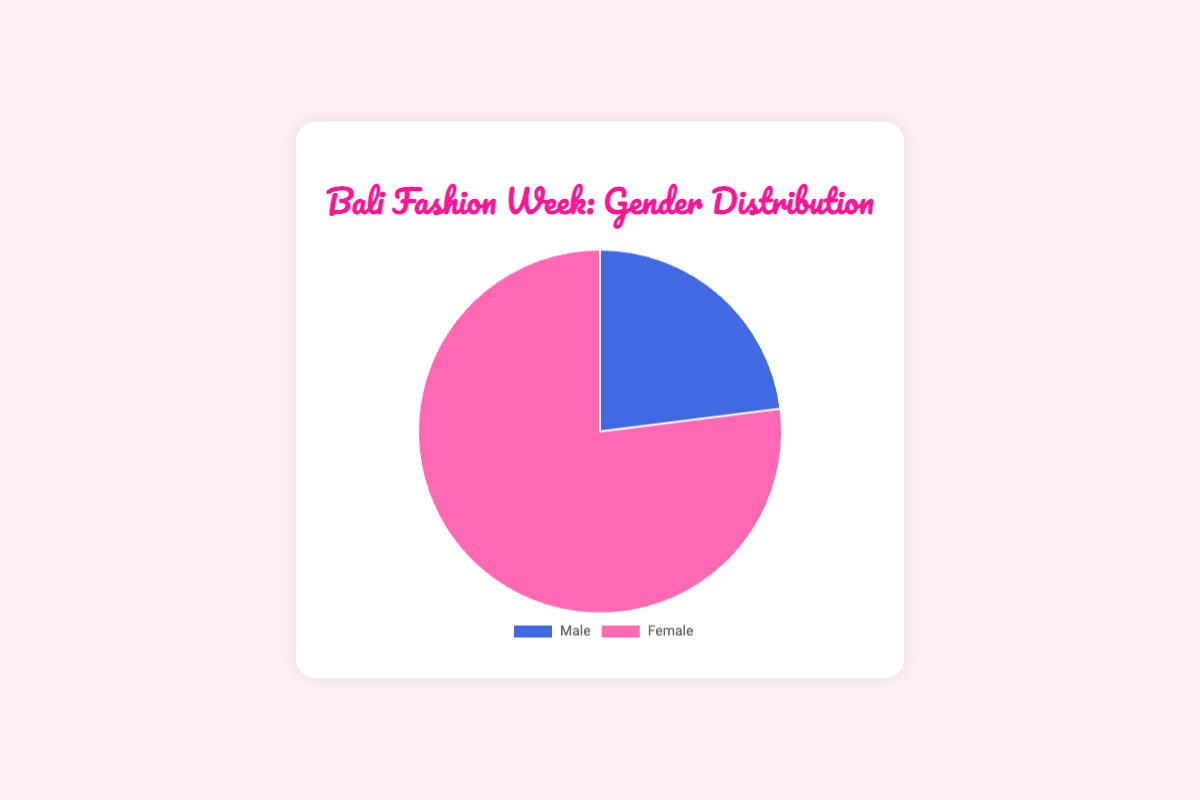What is the total percentage of female participants in Bali Fashion Week? The chart shows that the percentage of female participants in Bali Fashion Week is given directly. You can see it occupies a larger portion of the pie chart with 77%.
Answer: 77% What is the ratio of male to female participants in Bali Fashion Week? The chart shows there are 23 male participants and 77 female participants. The ratio is calculated by dividing the number of male participants by the number of female participants. Thus, the ratio is 23/77. Simplifying this fraction gives approximately 0.3. In other words, the proportion is 23:77.
Answer: 23:77 How much larger is the percentage of female participants compared to male participants in Bali Fashion Week? The chart shows the percentages of male and female participants are 23% and 77% respectively. The difference between these percentages is calculated as 77% - 23% = 54%.
Answer: 54% What is the percentage difference between male and female participants in Bali Fashion Week? To find the percentage difference between the two groups, subtract the male participation percentage (23%) from the female participation percentage (77%), which gives 54%.
Answer: 54% What is the proportion of female participants in Bali Fashion Week relative to the total number of participants? To determine the proportion of female participants, take the number of female participants (77) and divide it by the total number of participants (100). This equals 0.77 or 77%.
Answer: 77% Which gender has a larger proportion in Bali Fashion Week? Observing the pie chart, the female section clearly takes up a larger portion of the chart compared to the male section. Females have 77%, while males have 23%.
Answer: Female If the number of male participants increases by 10, what would be the new percentage of male participants? Original male participants are 23. Adding 10 more makes it 33. The total participants now are 23 + 77 + 10 = 110. The new percentage for males is (33/110) * 100 = 30%.
Answer: 30% What would be the new percentage of female participants if 5 female participants were removed? The original number of female participants is 77. Removing 5 makes it 72. The total participants now are 23 + 77 - 5 = 95. The new percentage for females is (72/95) * 100 ≈ 75.8%.
Answer: 75.8% 